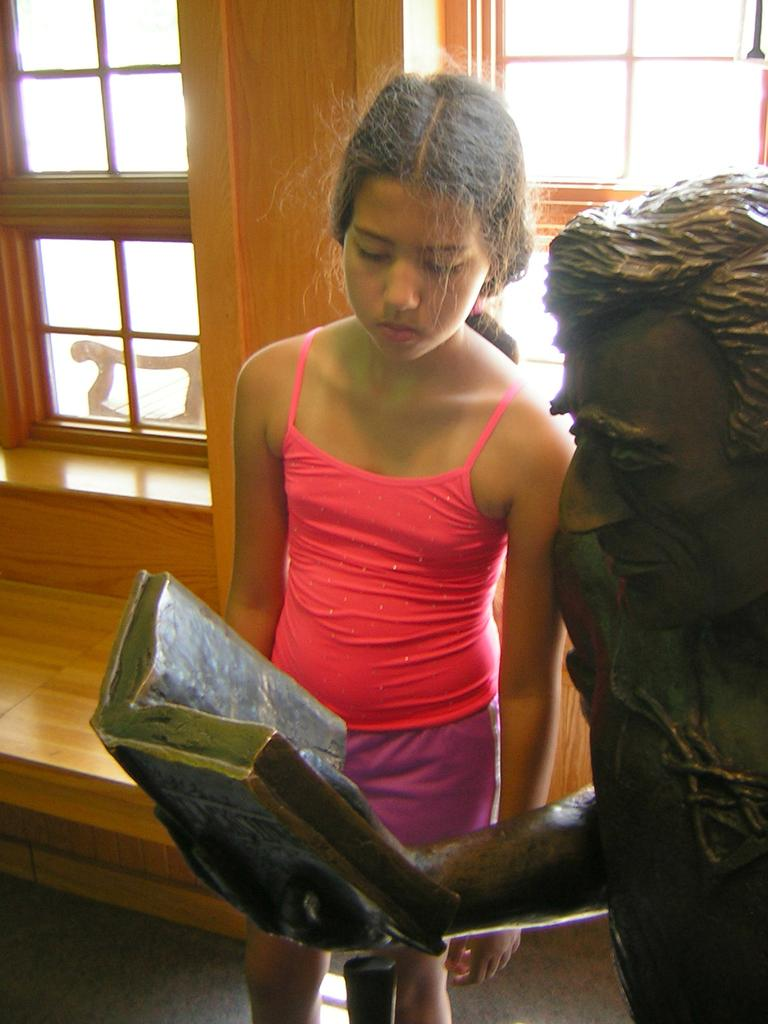Who is the main subject in the image? There is a girl in the image. What is the girl wearing? The girl is wearing a pink vest and purple shorts. Who else is present in the image? There is a man in the image. What is the man holding? The man is holding a book statue. What can be seen on the wall in the background of the image? There are windows on the wall in the background of the image. What type of wheel is visible in the image? There is no wheel present in the image. Who is the daughter of the man in the image? The facts provided do not mention any familial relationships between the girl and the man, so we cannot determine if the girl is the man's daughter. 